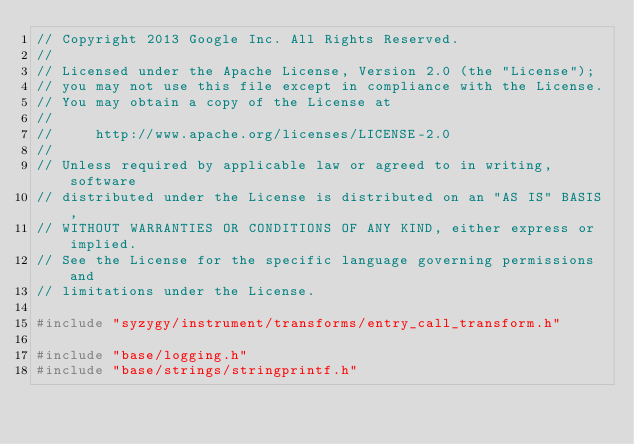<code> <loc_0><loc_0><loc_500><loc_500><_C++_>// Copyright 2013 Google Inc. All Rights Reserved.
//
// Licensed under the Apache License, Version 2.0 (the "License");
// you may not use this file except in compliance with the License.
// You may obtain a copy of the License at
//
//     http://www.apache.org/licenses/LICENSE-2.0
//
// Unless required by applicable law or agreed to in writing, software
// distributed under the License is distributed on an "AS IS" BASIS,
// WITHOUT WARRANTIES OR CONDITIONS OF ANY KIND, either express or implied.
// See the License for the specific language governing permissions and
// limitations under the License.

#include "syzygy/instrument/transforms/entry_call_transform.h"

#include "base/logging.h"
#include "base/strings/stringprintf.h"</code> 